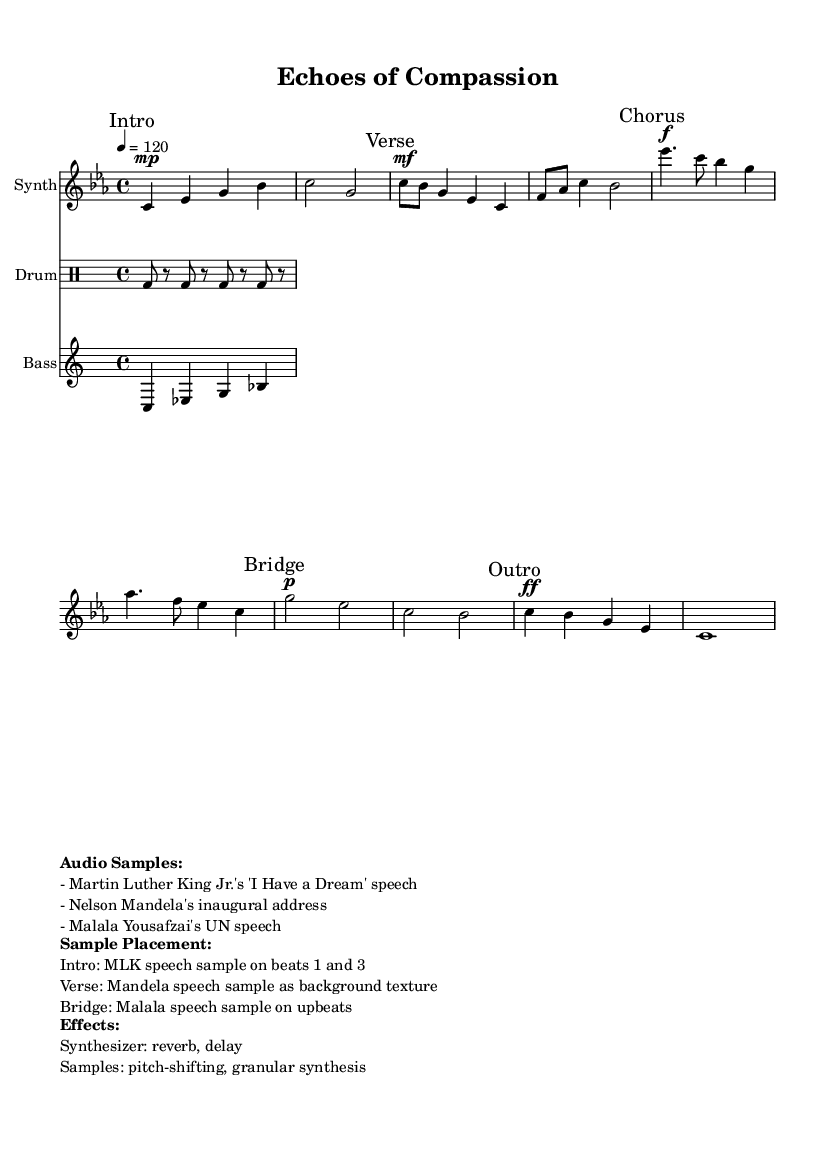What is the key signature of this music? The key signature specified in the sheet music is C minor, which consists of three flats (B-flat, E-flat, and A-flat). This is indicated at the beginning of the piece.
Answer: C minor What is the time signature of this music? The time signature is shown prominently in the sheet music and is 4/4, which means there are four beats in a measure and the quarter note receives one beat.
Answer: 4/4 What is the tempo marking of the piece? The tempo marking is indicated by the text notation at the beginning of the music, stating a speed of 120 beats per minute, indicating how fast the piece should be played.
Answer: 120 Which speech sample is used in the Intro section? The Intro section specifies that it includes Martin Luther King Jr.'s "I Have a Dream" speech sample on beats one and three, which provides thematic significance to the section.
Answer: MLK speech How does the Bridge section utilize audio samples? The Bridge section incorporates Malala Yousafzai's UN speech sample on upbeats, enhancing the emotional impact of the transition within the piece by aligning it with themes of empowerment.
Answer: Malala speech What effects are applied to the synthesizer in this piece? The sheet music indicates that effects applied to the synthesizer include reverb and delay, which are commonly used in electronic music to create depth and space in the sound.
Answer: Reverb, delay What is the primary instrument type used in this composition? The primary instrument type indicated in the score is a synthesizer, which is characteristic of electronic music, providing a wide range of sounds and textures.
Answer: Synthesizer 